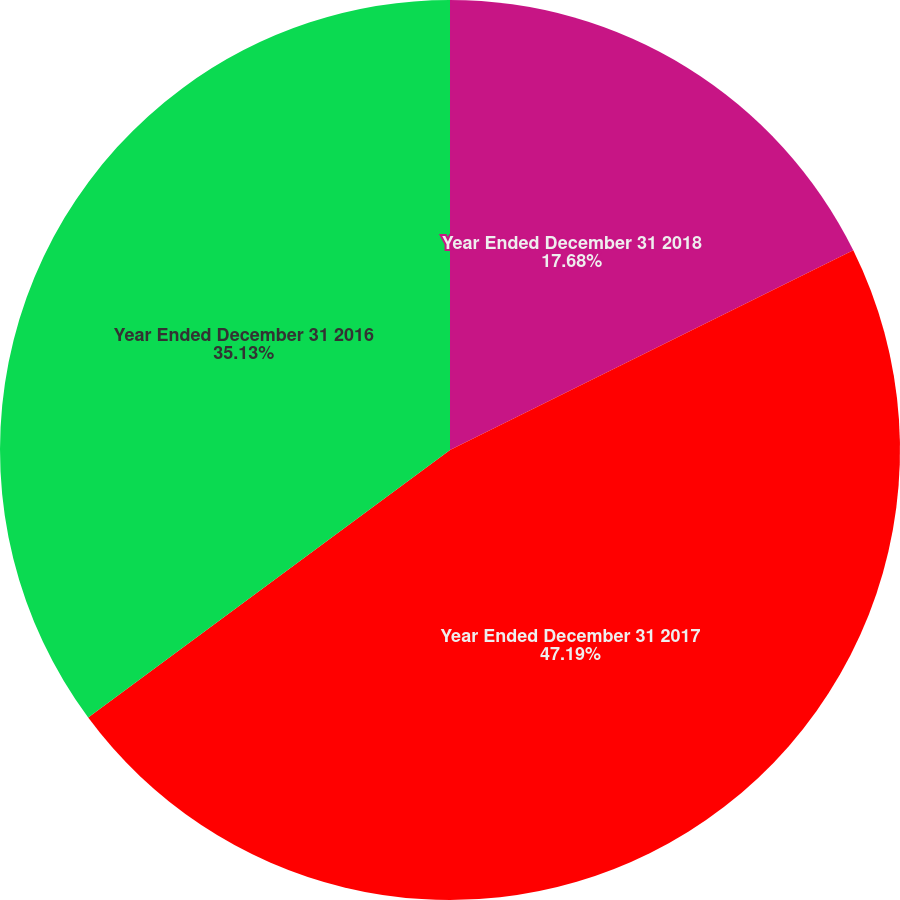Convert chart. <chart><loc_0><loc_0><loc_500><loc_500><pie_chart><fcel>Year Ended December 31 2018<fcel>Year Ended December 31 2017<fcel>Year Ended December 31 2016<nl><fcel>17.68%<fcel>47.18%<fcel>35.13%<nl></chart> 